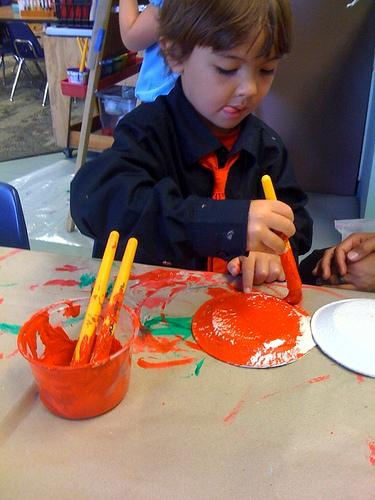Which one of the paint is safe for children art work?

Choices:
A) enamel paint
B) acrylic paint
C) oil paint
D) emulsion paint acrylic paint 